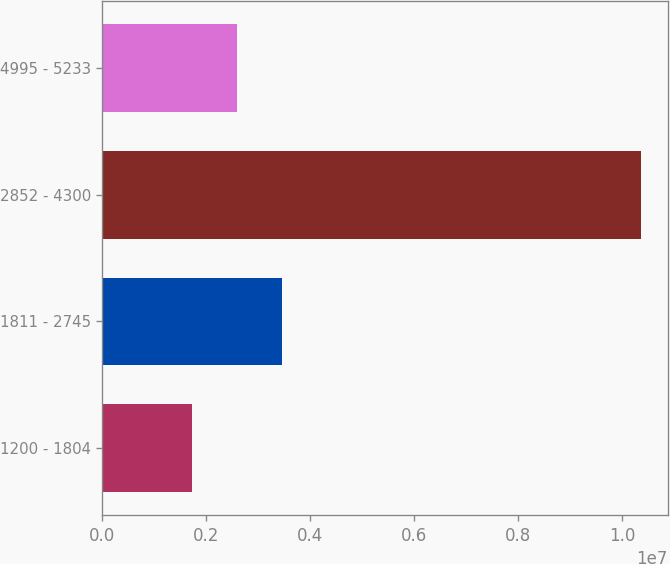Convert chart. <chart><loc_0><loc_0><loc_500><loc_500><bar_chart><fcel>1200 - 1804<fcel>1811 - 2745<fcel>2852 - 4300<fcel>4995 - 5233<nl><fcel>1.73133e+06<fcel>3.4565e+06<fcel>1.03572e+07<fcel>2.59392e+06<nl></chart> 